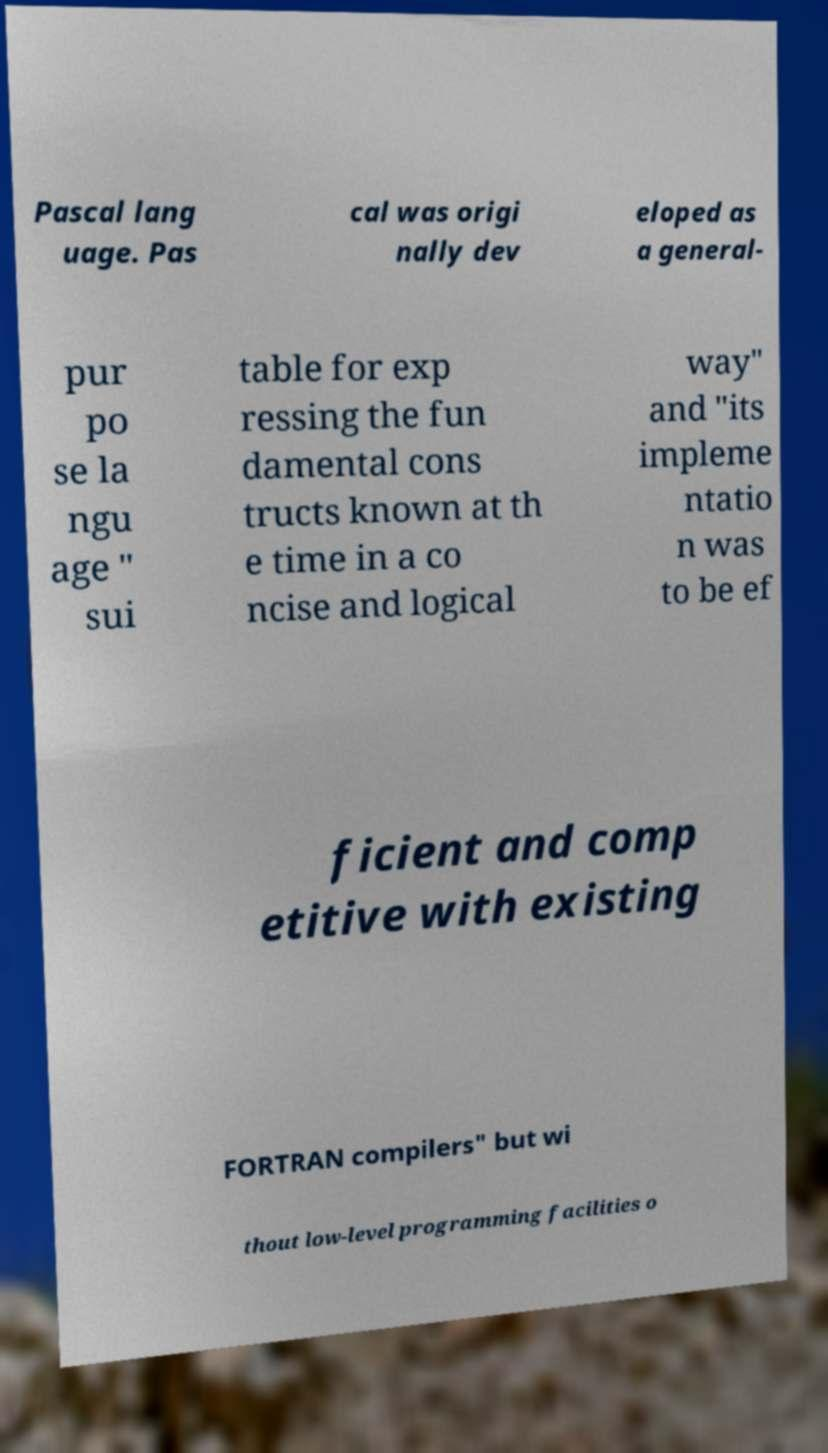What messages or text are displayed in this image? I need them in a readable, typed format. Pascal lang uage. Pas cal was origi nally dev eloped as a general- pur po se la ngu age " sui table for exp ressing the fun damental cons tructs known at th e time in a co ncise and logical way" and "its impleme ntatio n was to be ef ficient and comp etitive with existing FORTRAN compilers" but wi thout low-level programming facilities o 